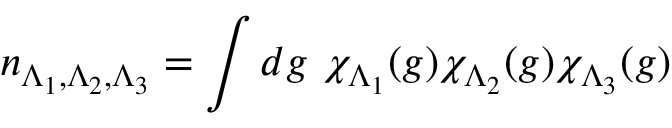Convert formula to latex. <formula><loc_0><loc_0><loc_500><loc_500>n _ { \Lambda _ { 1 } , \Lambda _ { 2 } , \Lambda _ { 3 } } = \int d g \ \chi _ { \Lambda _ { 1 } } ( g ) \chi _ { \Lambda _ { 2 } } ( g ) \chi _ { \Lambda _ { 3 } } ( g )</formula> 